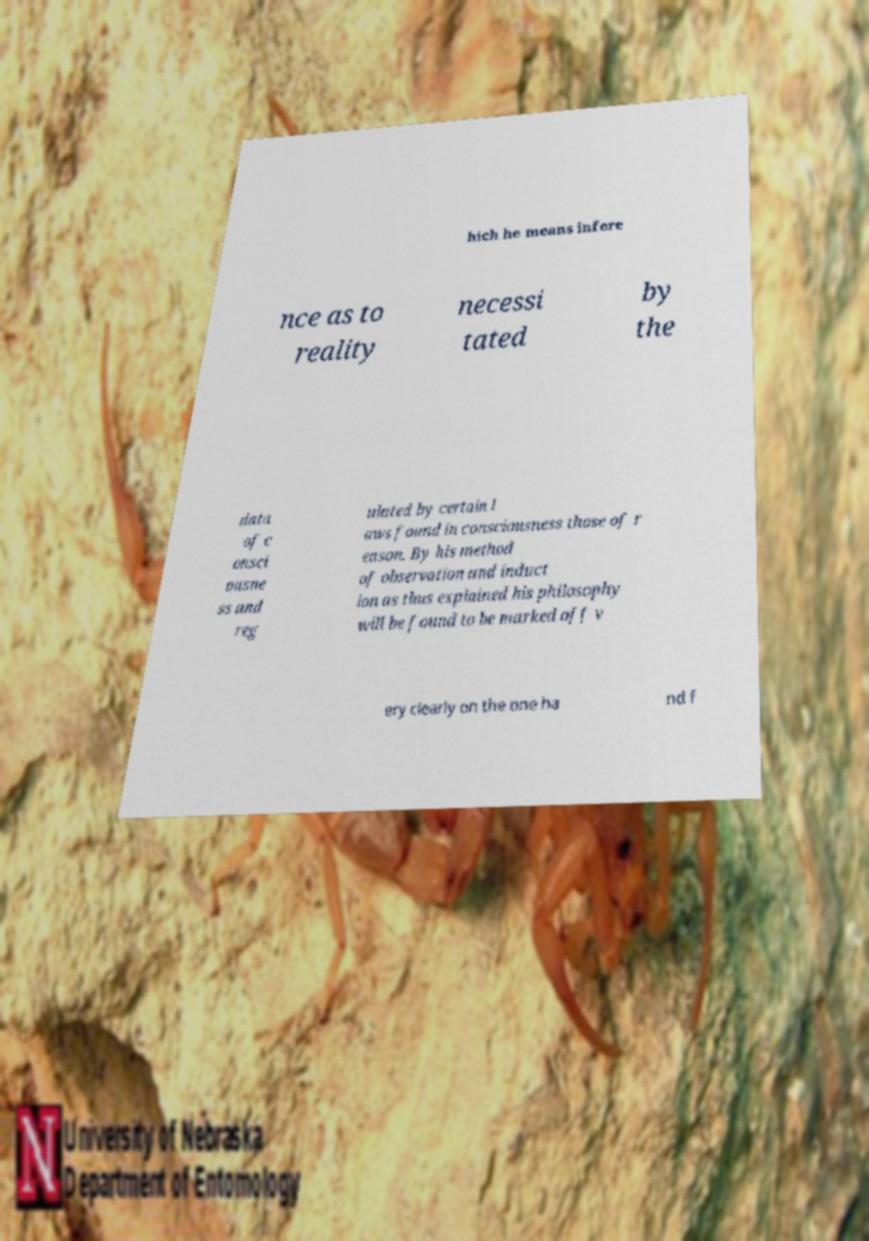Could you assist in decoding the text presented in this image and type it out clearly? hich he means infere nce as to reality necessi tated by the data of c onsci ousne ss and reg ulated by certain l aws found in consciousness those of r eason. By his method of observation and induct ion as thus explained his philosophy will be found to be marked off v ery clearly on the one ha nd f 